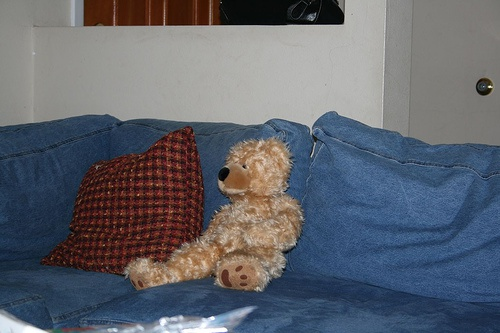Describe the objects in this image and their specific colors. I can see couch in gray, blue, and navy tones and teddy bear in gray and tan tones in this image. 